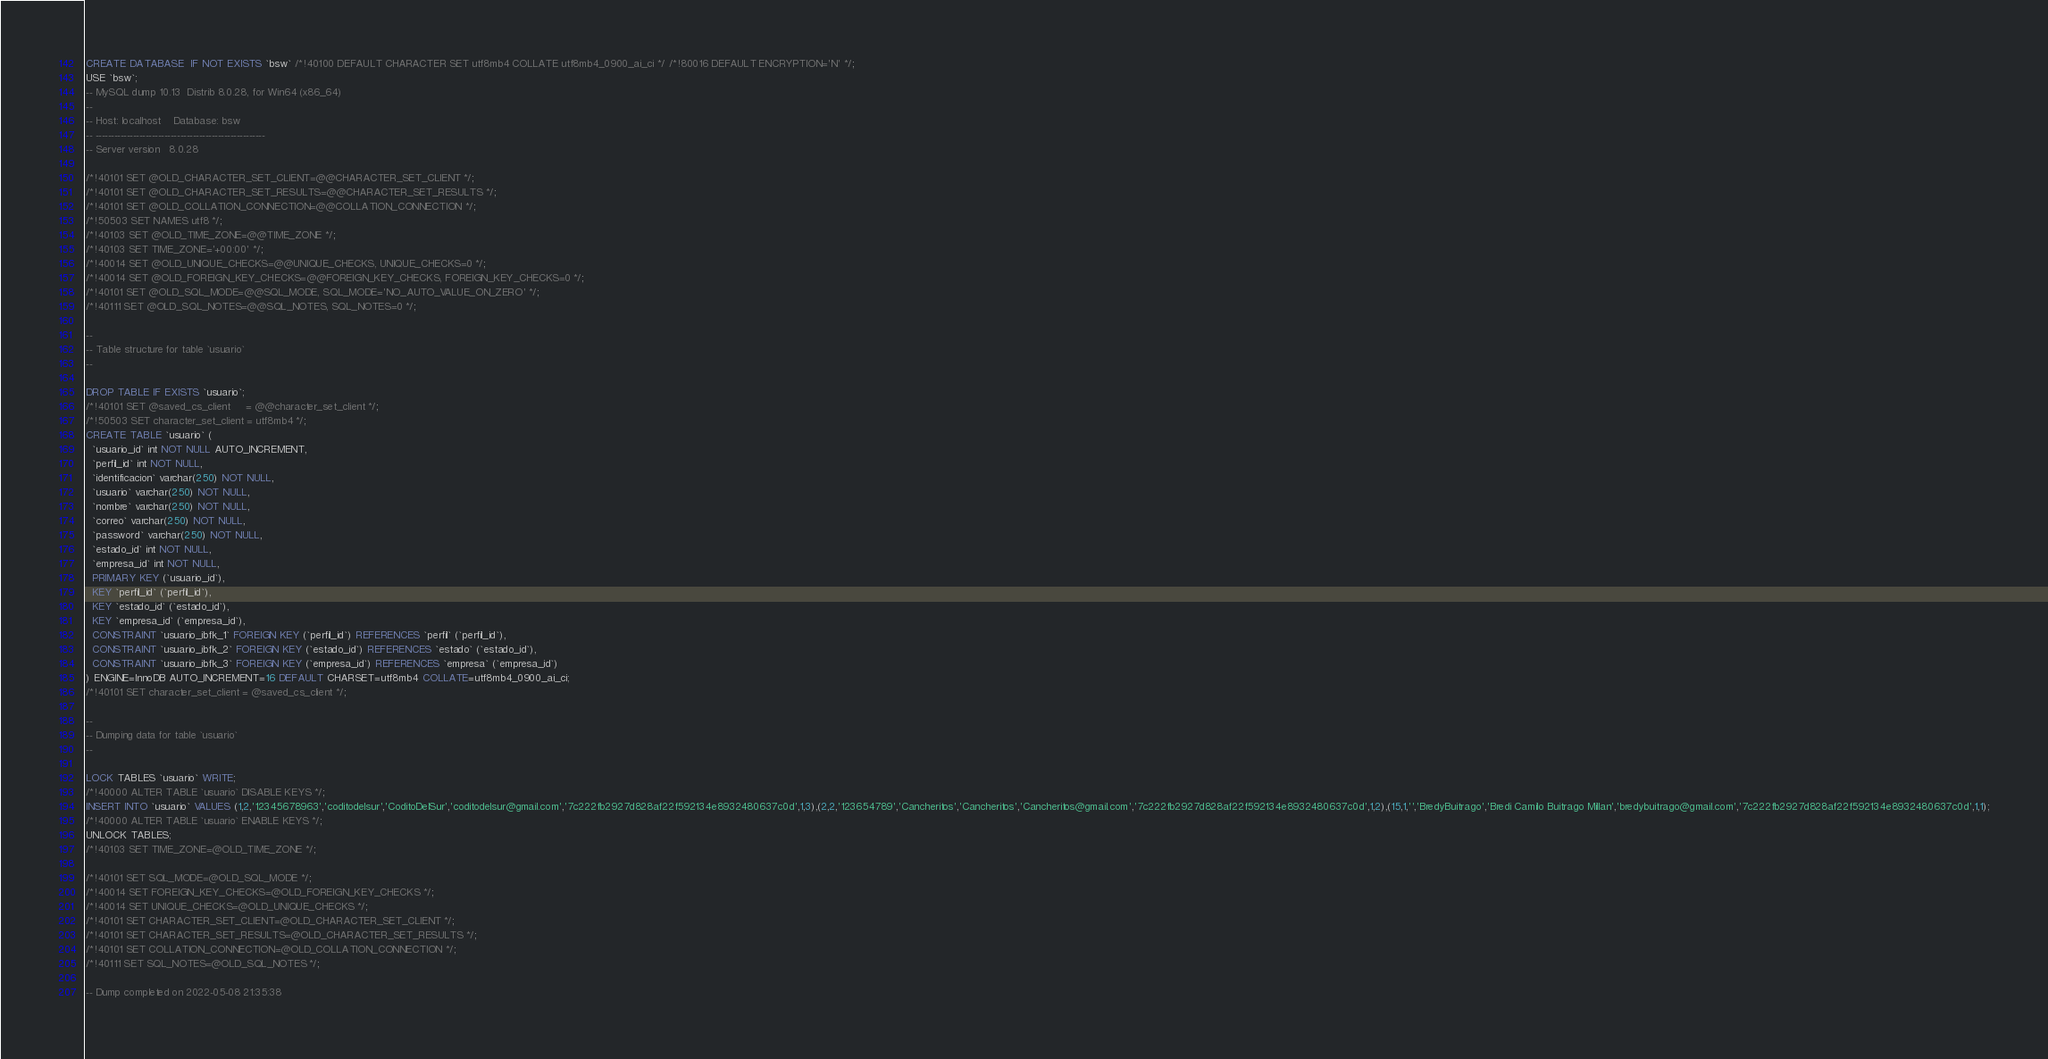<code> <loc_0><loc_0><loc_500><loc_500><_SQL_>CREATE DATABASE  IF NOT EXISTS `bsw` /*!40100 DEFAULT CHARACTER SET utf8mb4 COLLATE utf8mb4_0900_ai_ci */ /*!80016 DEFAULT ENCRYPTION='N' */;
USE `bsw`;
-- MySQL dump 10.13  Distrib 8.0.28, for Win64 (x86_64)
--
-- Host: localhost    Database: bsw
-- ------------------------------------------------------
-- Server version	8.0.28

/*!40101 SET @OLD_CHARACTER_SET_CLIENT=@@CHARACTER_SET_CLIENT */;
/*!40101 SET @OLD_CHARACTER_SET_RESULTS=@@CHARACTER_SET_RESULTS */;
/*!40101 SET @OLD_COLLATION_CONNECTION=@@COLLATION_CONNECTION */;
/*!50503 SET NAMES utf8 */;
/*!40103 SET @OLD_TIME_ZONE=@@TIME_ZONE */;
/*!40103 SET TIME_ZONE='+00:00' */;
/*!40014 SET @OLD_UNIQUE_CHECKS=@@UNIQUE_CHECKS, UNIQUE_CHECKS=0 */;
/*!40014 SET @OLD_FOREIGN_KEY_CHECKS=@@FOREIGN_KEY_CHECKS, FOREIGN_KEY_CHECKS=0 */;
/*!40101 SET @OLD_SQL_MODE=@@SQL_MODE, SQL_MODE='NO_AUTO_VALUE_ON_ZERO' */;
/*!40111 SET @OLD_SQL_NOTES=@@SQL_NOTES, SQL_NOTES=0 */;

--
-- Table structure for table `usuario`
--

DROP TABLE IF EXISTS `usuario`;
/*!40101 SET @saved_cs_client     = @@character_set_client */;
/*!50503 SET character_set_client = utf8mb4 */;
CREATE TABLE `usuario` (
  `usuario_id` int NOT NULL AUTO_INCREMENT,
  `perfil_id` int NOT NULL,
  `identificacion` varchar(250) NOT NULL,
  `usuario` varchar(250) NOT NULL,
  `nombre` varchar(250) NOT NULL,
  `correo` varchar(250) NOT NULL,
  `password` varchar(250) NOT NULL,
  `estado_id` int NOT NULL,
  `empresa_id` int NOT NULL,
  PRIMARY KEY (`usuario_id`),
  KEY `perfil_id` (`perfil_id`),
  KEY `estado_id` (`estado_id`),
  KEY `empresa_id` (`empresa_id`),
  CONSTRAINT `usuario_ibfk_1` FOREIGN KEY (`perfil_id`) REFERENCES `perfil` (`perfil_id`),
  CONSTRAINT `usuario_ibfk_2` FOREIGN KEY (`estado_id`) REFERENCES `estado` (`estado_id`),
  CONSTRAINT `usuario_ibfk_3` FOREIGN KEY (`empresa_id`) REFERENCES `empresa` (`empresa_id`)
) ENGINE=InnoDB AUTO_INCREMENT=16 DEFAULT CHARSET=utf8mb4 COLLATE=utf8mb4_0900_ai_ci;
/*!40101 SET character_set_client = @saved_cs_client */;

--
-- Dumping data for table `usuario`
--

LOCK TABLES `usuario` WRITE;
/*!40000 ALTER TABLE `usuario` DISABLE KEYS */;
INSERT INTO `usuario` VALUES (1,2,'12345678963','coditodelsur','CoditoDelSur','coditodelsur@gmail.com','7c222fb2927d828af22f592134e8932480637c0d',1,3),(2,2,'123654789','Cancheritos','Cancheritos','Cancheritos@gmail.com','7c222fb2927d828af22f592134e8932480637c0d',1,2),(15,1,'','BredyBuitrago','Bredi Camilo Buitrago Millan','bredybuitrago@gmail.com','7c222fb2927d828af22f592134e8932480637c0d',1,1);
/*!40000 ALTER TABLE `usuario` ENABLE KEYS */;
UNLOCK TABLES;
/*!40103 SET TIME_ZONE=@OLD_TIME_ZONE */;

/*!40101 SET SQL_MODE=@OLD_SQL_MODE */;
/*!40014 SET FOREIGN_KEY_CHECKS=@OLD_FOREIGN_KEY_CHECKS */;
/*!40014 SET UNIQUE_CHECKS=@OLD_UNIQUE_CHECKS */;
/*!40101 SET CHARACTER_SET_CLIENT=@OLD_CHARACTER_SET_CLIENT */;
/*!40101 SET CHARACTER_SET_RESULTS=@OLD_CHARACTER_SET_RESULTS */;
/*!40101 SET COLLATION_CONNECTION=@OLD_COLLATION_CONNECTION */;
/*!40111 SET SQL_NOTES=@OLD_SQL_NOTES */;

-- Dump completed on 2022-05-08 21:35:38
</code> 